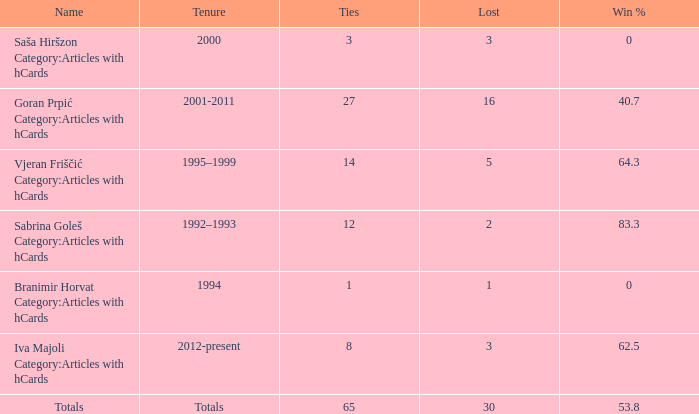Tell me the total number of ties for name of totals and lost more than 30 0.0. 